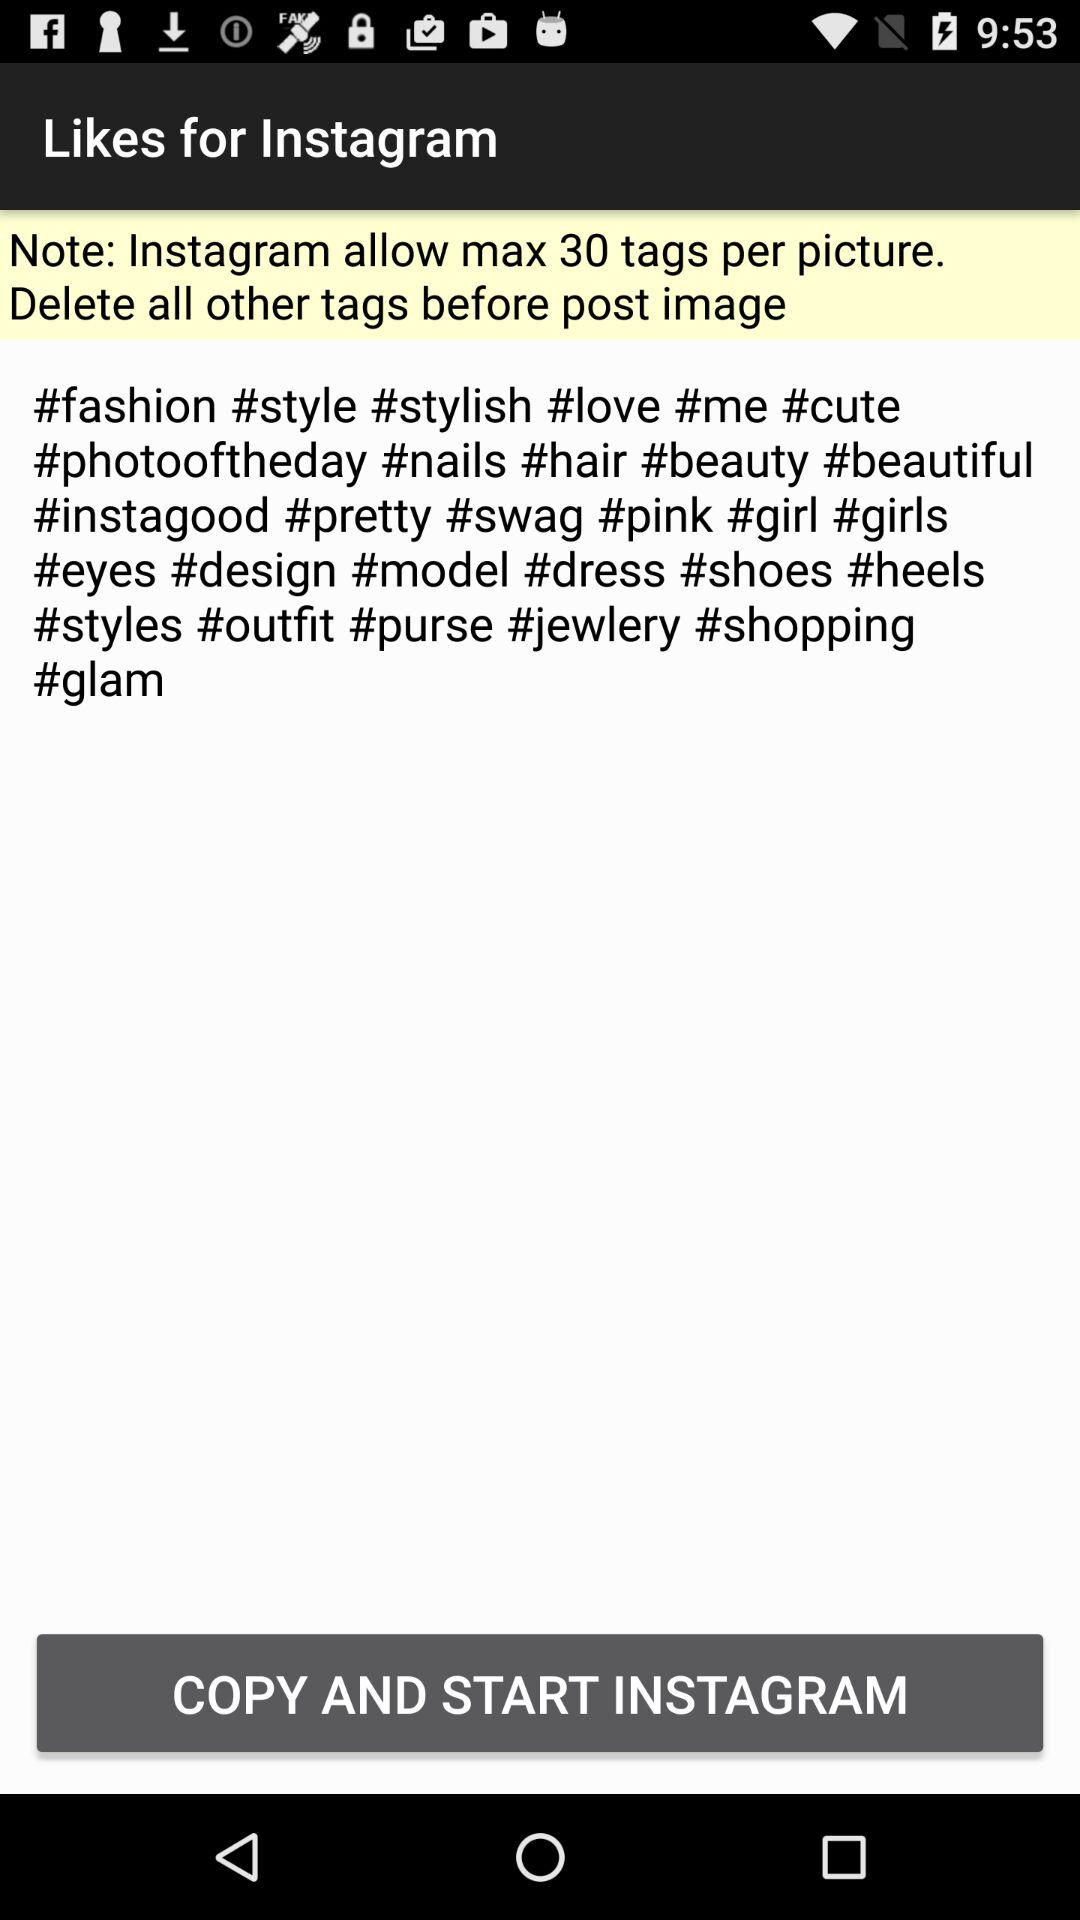What's the maximum number of tags per picture allowed on Instagram? Instagram allows a maximum of 30 tags per picture. 